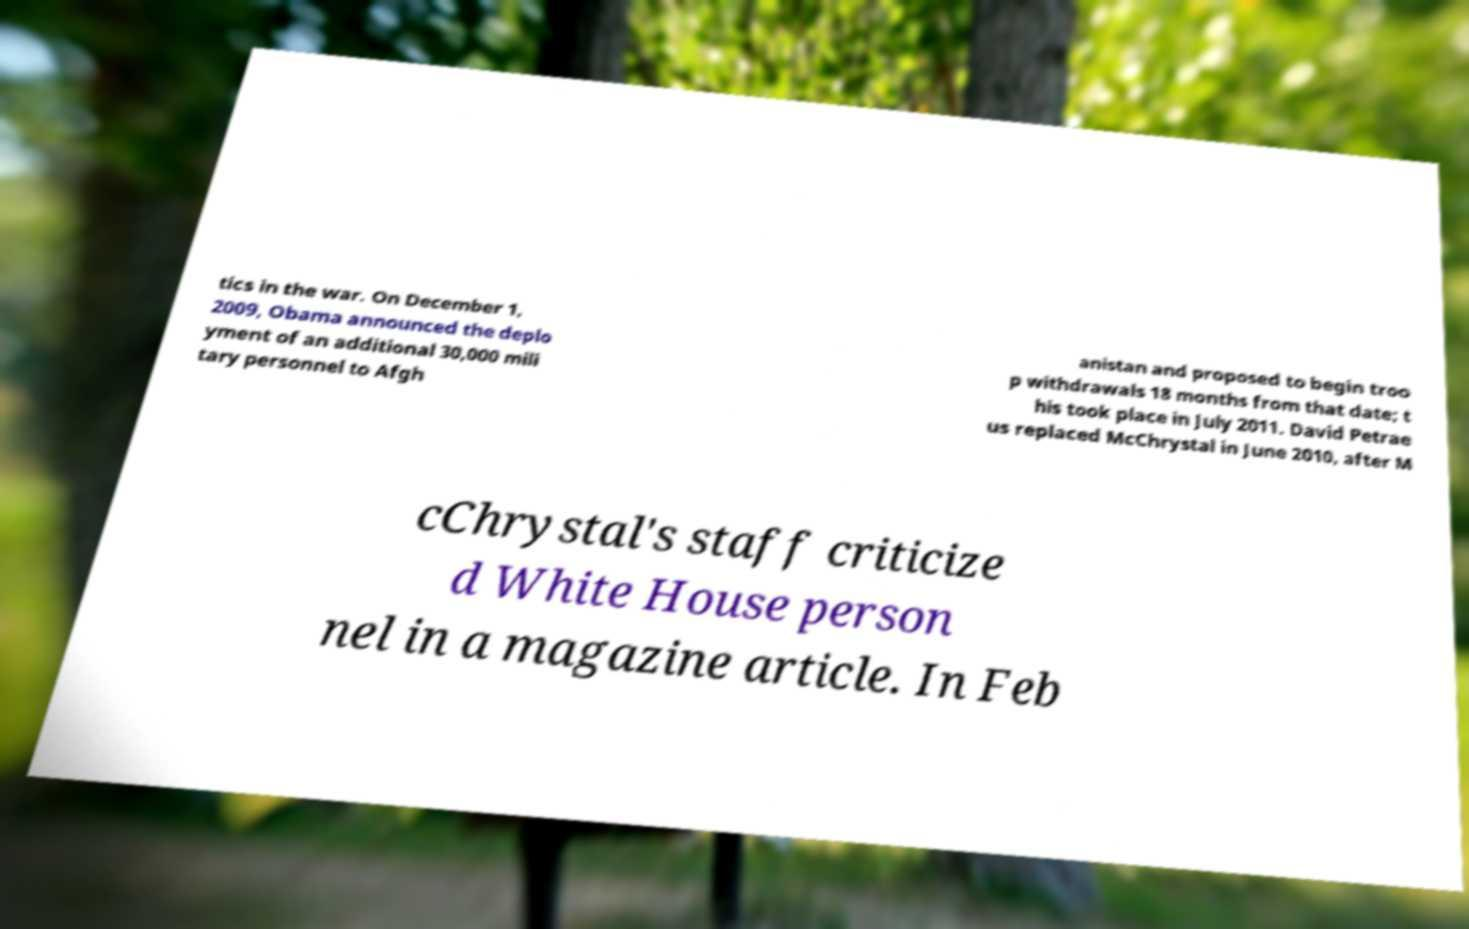There's text embedded in this image that I need extracted. Can you transcribe it verbatim? tics in the war. On December 1, 2009, Obama announced the deplo yment of an additional 30,000 mili tary personnel to Afgh anistan and proposed to begin troo p withdrawals 18 months from that date; t his took place in July 2011. David Petrae us replaced McChrystal in June 2010, after M cChrystal's staff criticize d White House person nel in a magazine article. In Feb 